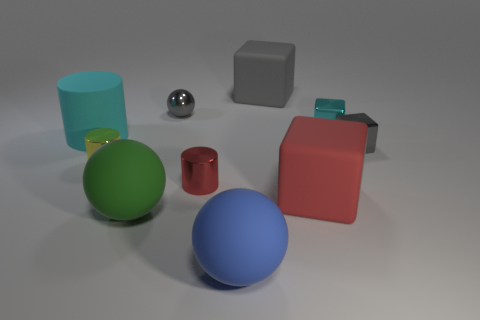Do the large green rubber object and the small red object have the same shape?
Give a very brief answer. No. There is another tiny metallic object that is the same shape as the small cyan shiny thing; what is its color?
Your answer should be very brief. Gray. What number of small blocks have the same color as the matte cylinder?
Give a very brief answer. 1. How many things are either objects that are on the right side of the large cyan object or blue matte spheres?
Your answer should be compact. 9. There is a sphere behind the red cylinder; what is its size?
Your response must be concise. Small. Is the number of yellow metallic cylinders less than the number of objects?
Your answer should be very brief. Yes. Is the large cube that is in front of the gray rubber block made of the same material as the big block that is behind the small cyan metallic block?
Offer a terse response. Yes. The green rubber thing that is to the left of the matte thing to the right of the big thing behind the cyan rubber object is what shape?
Make the answer very short. Sphere. How many large cyan things are the same material as the large gray object?
Provide a short and direct response. 1. There is a big green object in front of the tiny yellow shiny thing; how many small metallic things are to the left of it?
Your answer should be compact. 1. 